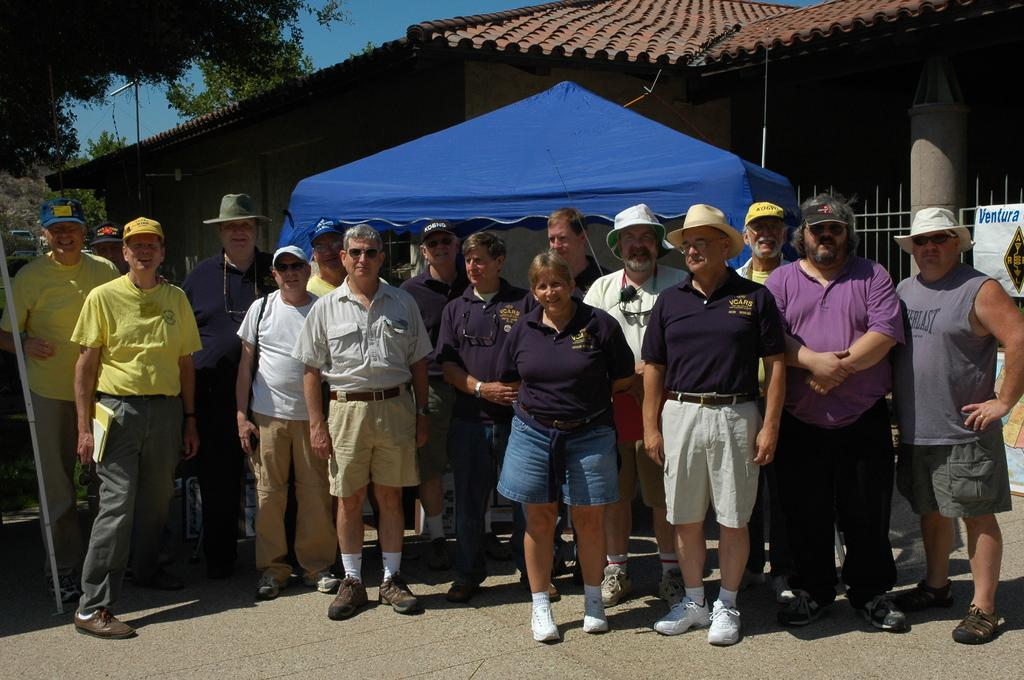What can be seen in the background of the image? In the background of the image, there is a sky, trees, a rooftop, a fence, and a banner. What are the people in the image wearing? Some of the people in the image are wearing caps and goggles. What is the overall color tint of the image? The image has a blue color tint. How many geese are flying over the people in the image? There are no geese present in the image. What type of steel is used to construct the fence in the image? There is no information about the type of steel used in the fence, and the image does not show any steel. 